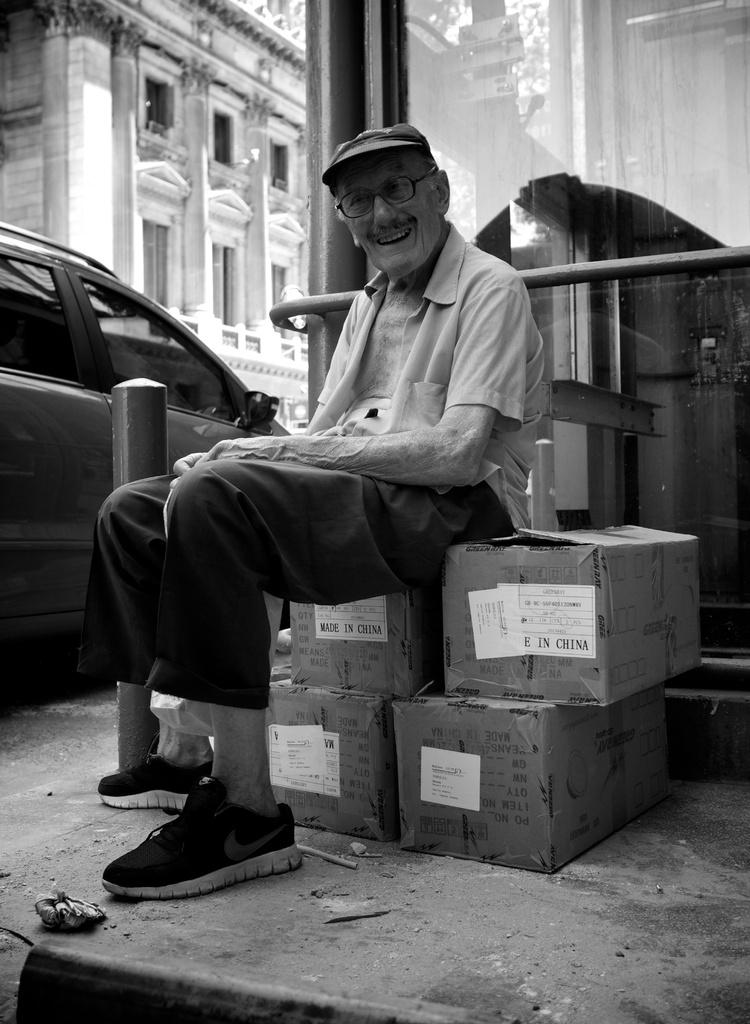What is the man in the image doing? The man is sitting on boxes in the center of the image. What can be seen in the background of the image? There is a building, a wall, a vehicle, and glass visible in the background of the image. What type of power is the fireman using to put out the current in the image? There is no fireman or current present in the image. 